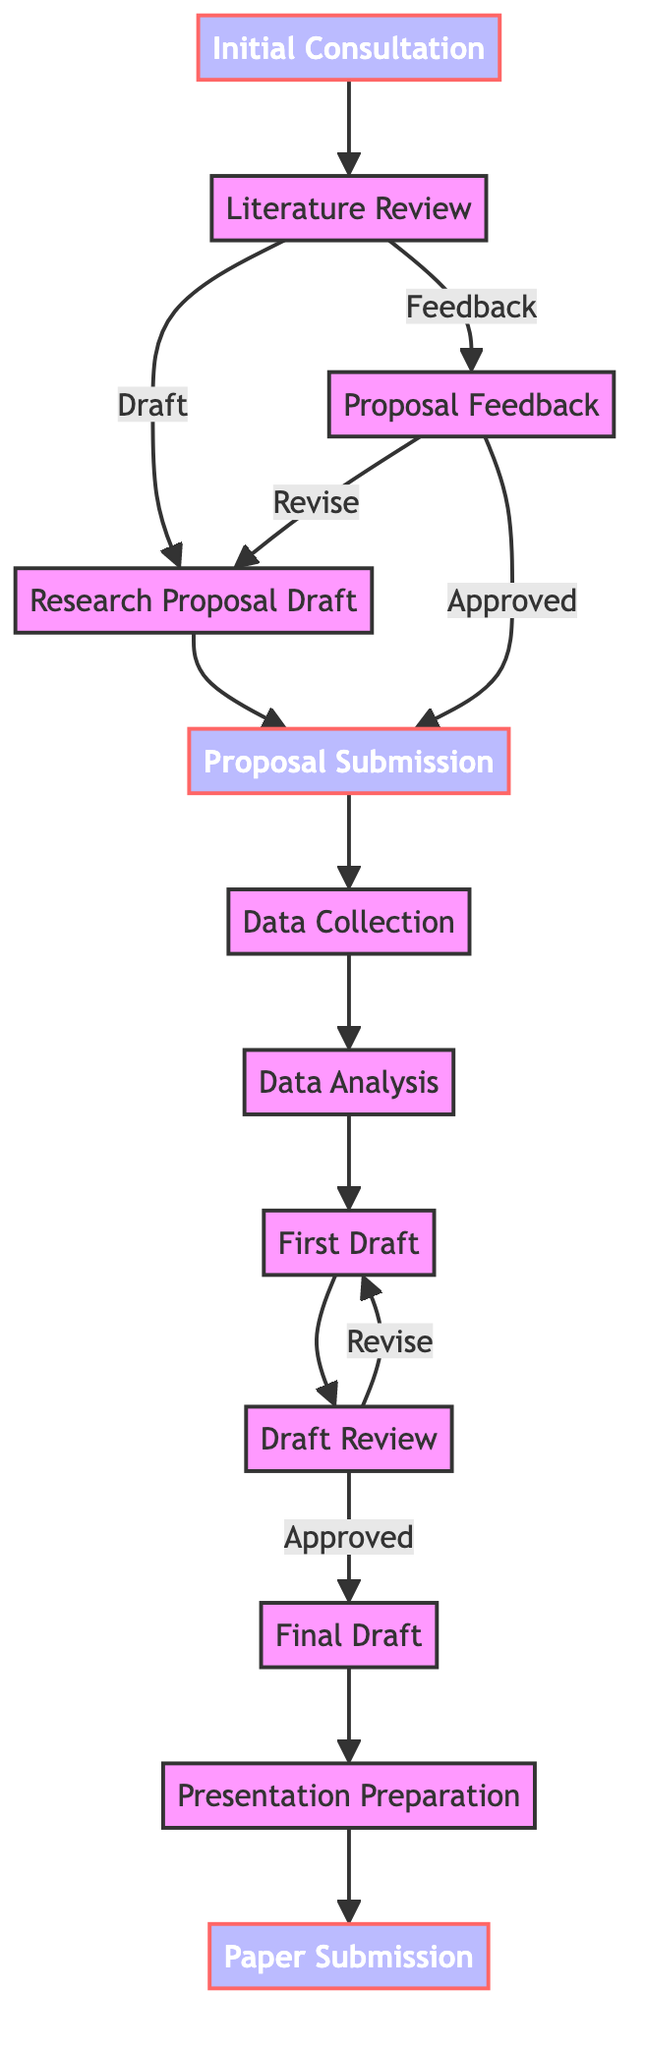What is the first step in the research project timeline? The first step is the "Initial Consultation" with Professor Adams. This is the starting point of the flowchart and leads to the next step, which is the "Literature Review."
Answer: Initial Consultation How many major milestones are identified in this flowchart? The flowchart identifies three major milestones marked with a specific style. They are the "Initial Consultation," "Proposal Submission," and "Paper Submission." Counting these milestones gives the answer.
Answer: 3 Which node comes after "Data Analysis"? The node that follows "Data Analysis" is "First Draft." This can be traced by looking at the directed flow from "Data Analysis" in the diagram.
Answer: First Draft What action follows the "Draft Review"? After the "Draft Review," the user can either revise the draft or approve it, leading to either "First Draft" again or the "Final Draft," respectively. This decision point indicates these possible paths.
Answer: Revise or Approved What is the relationship between "Research Proposal Draft" and "Proposal Submission"? The relationship is sequential; the "Research Proposal Draft" must be completed before moving on to "Proposal Submission." Hence, "Research Proposal Draft" flows directly into "Proposal Submission."
Answer: Sequential Which step is directly before the "Paper Submission"? The step directly preceding "Paper Submission" is "Presentation Preparation." The flowchart indicates this direct connection.
Answer: Presentation Preparation If feedback on the proposal draft is received, what is the next step? If feedback is received on the proposal draft, the next step is to revise it. The flowchart shows a connection leading back to the "Research Proposal Draft," indicating that revisions must be made before proceeding further.
Answer: Revise What must occur before data collection starts? Before data collection can commence, the research proposal needs to be submitted. This requirement is indicated by the flow from "Proposal Submission" leading into "Data Collection."
Answer: Proposal Submission What is the last step in the process according to the diagram? The last step in the process is "Paper Submission," marking the completion of the research project timeline. It's identified as having no subsequent steps following it in the flowchart.
Answer: Paper Submission 